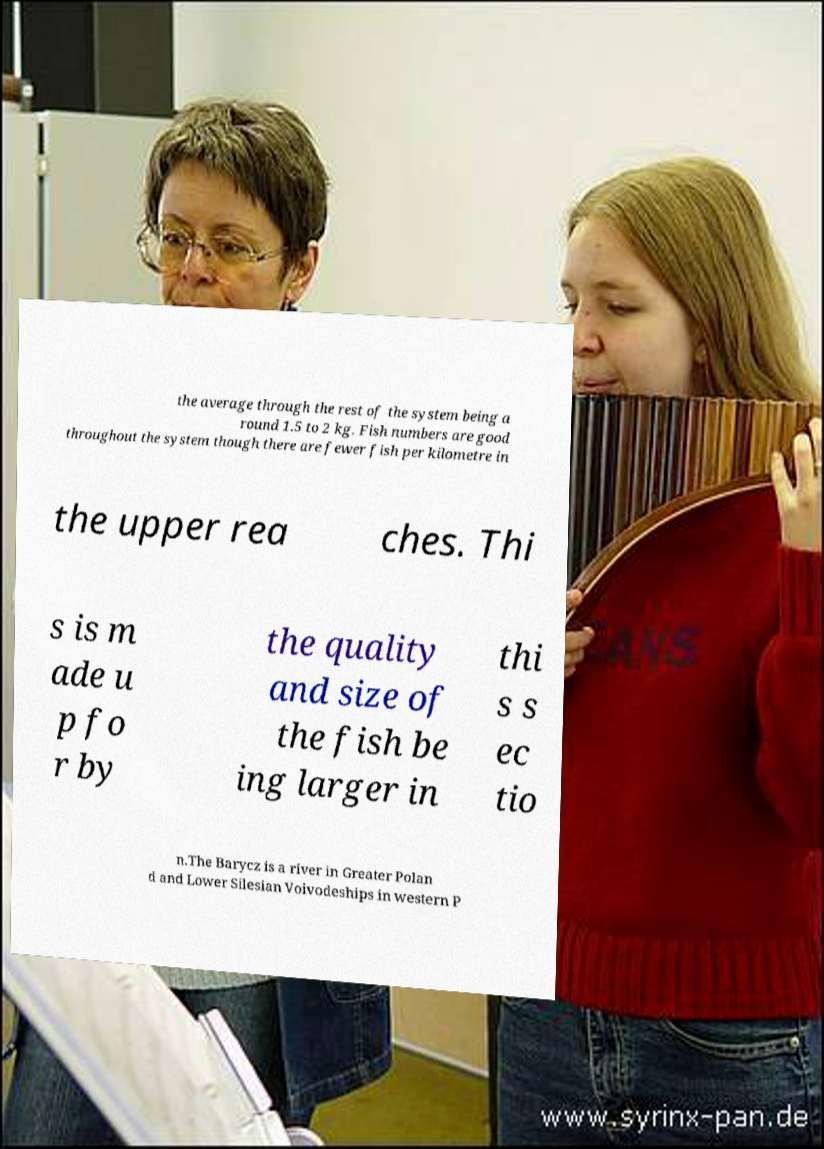I need the written content from this picture converted into text. Can you do that? the average through the rest of the system being a round 1.5 to 2 kg. Fish numbers are good throughout the system though there are fewer fish per kilometre in the upper rea ches. Thi s is m ade u p fo r by the quality and size of the fish be ing larger in thi s s ec tio n.The Barycz is a river in Greater Polan d and Lower Silesian Voivodeships in western P 